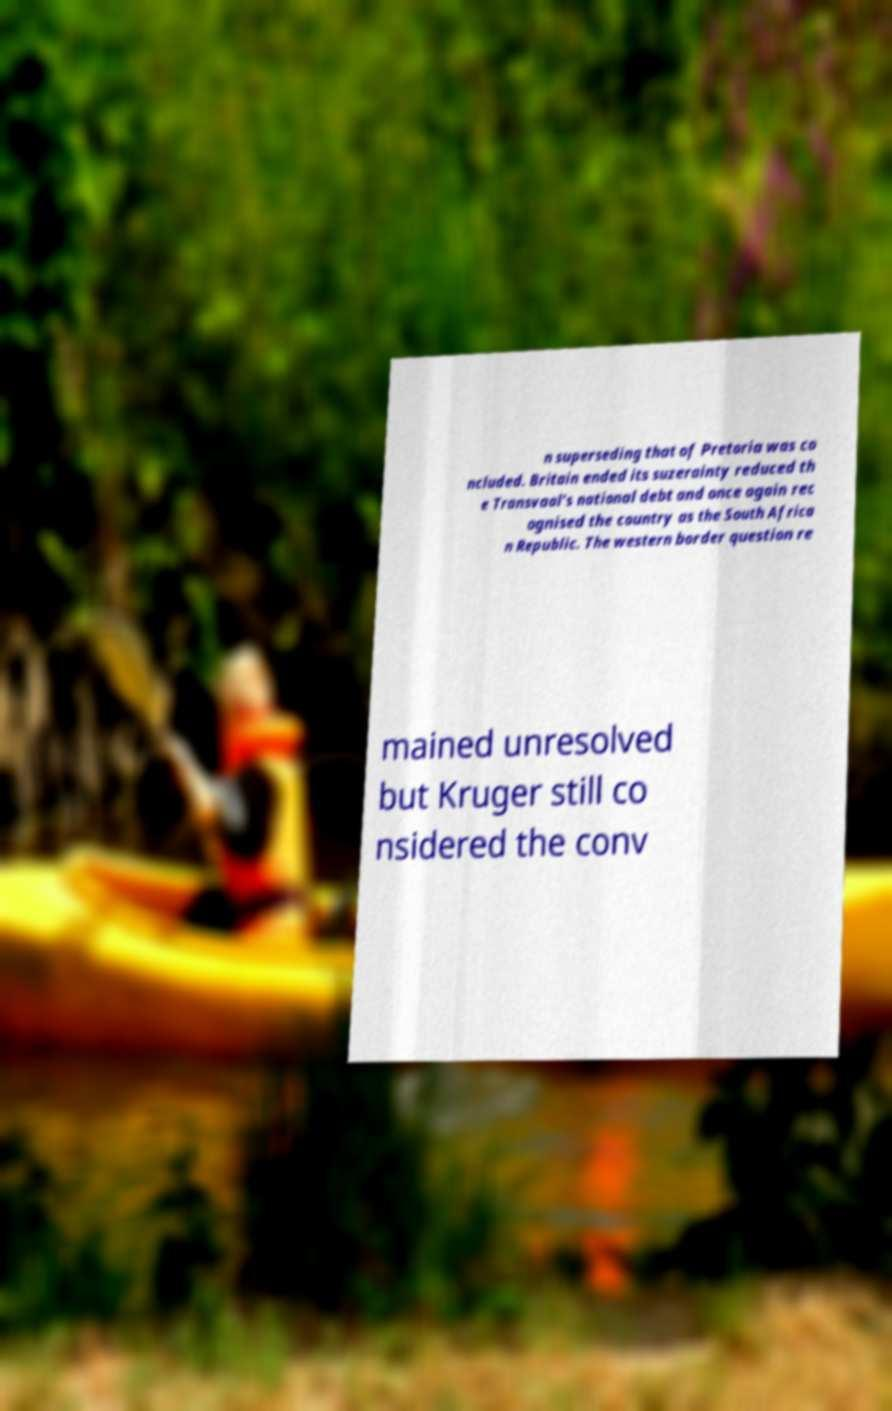For documentation purposes, I need the text within this image transcribed. Could you provide that? n superseding that of Pretoria was co ncluded. Britain ended its suzerainty reduced th e Transvaal's national debt and once again rec ognised the country as the South Africa n Republic. The western border question re mained unresolved but Kruger still co nsidered the conv 